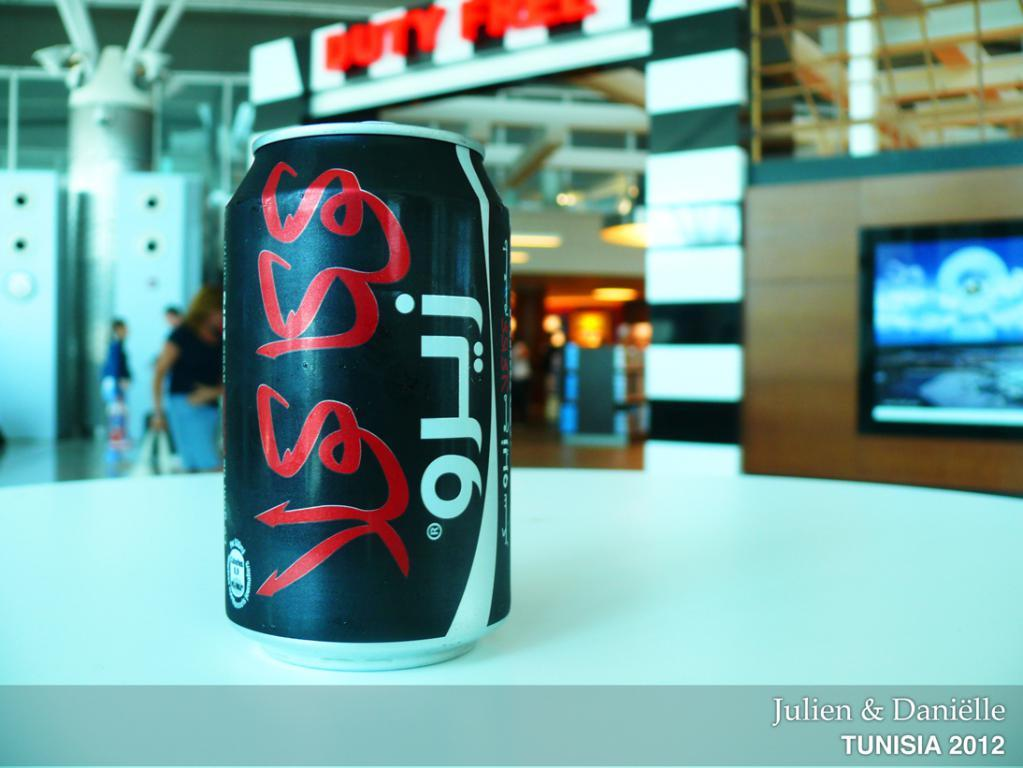<image>
Create a compact narrative representing the image presented. A photo of a can that is part of Julen and Danielle's Tunisia 2012 collection. 